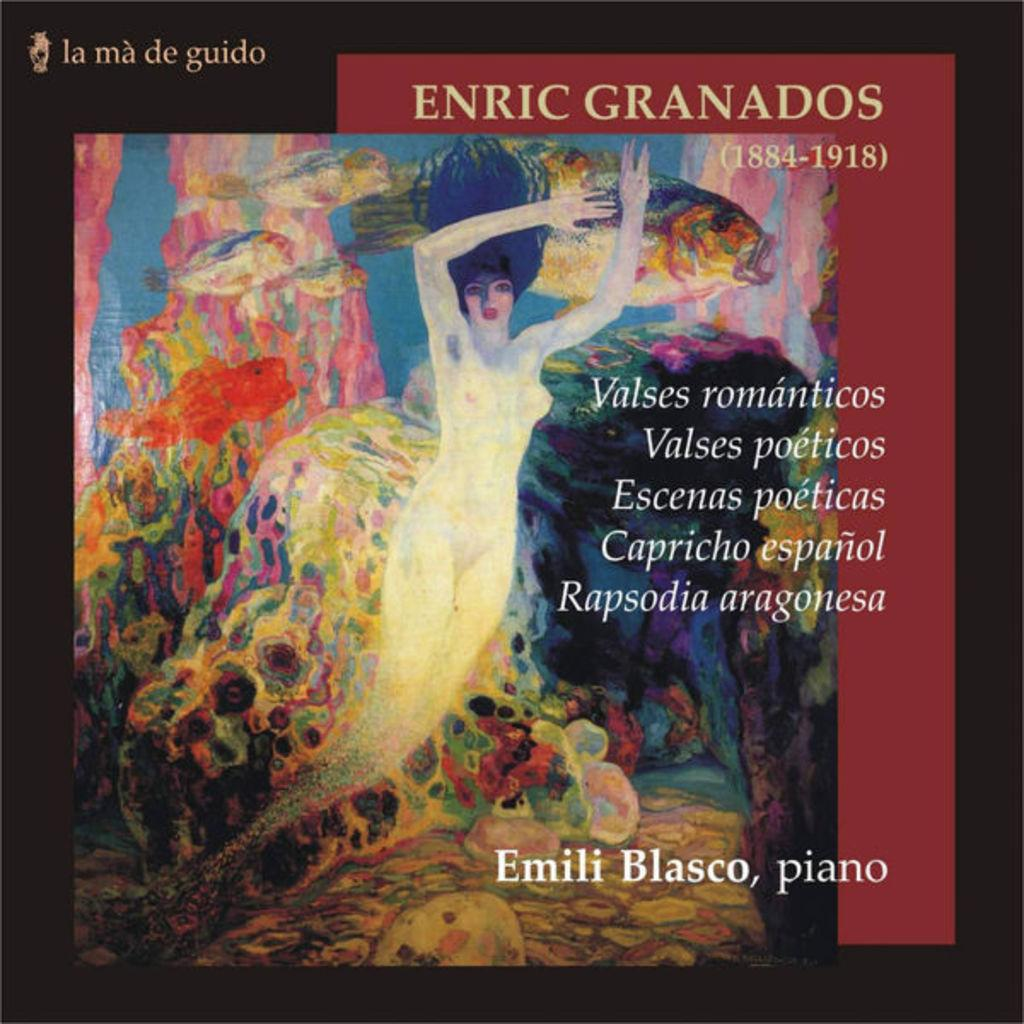<image>
Give a short and clear explanation of the subsequent image. Emili Blasco released an album of Enric Granados' piano music. 